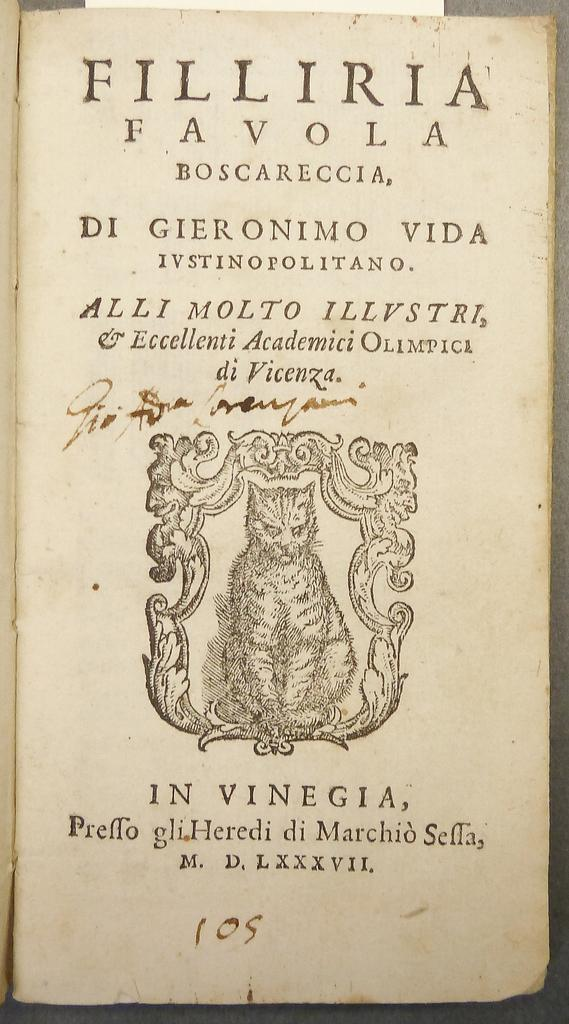<image>
Render a clear and concise summary of the photo. A book from the past bears the name Filliria Favola on its title page. 